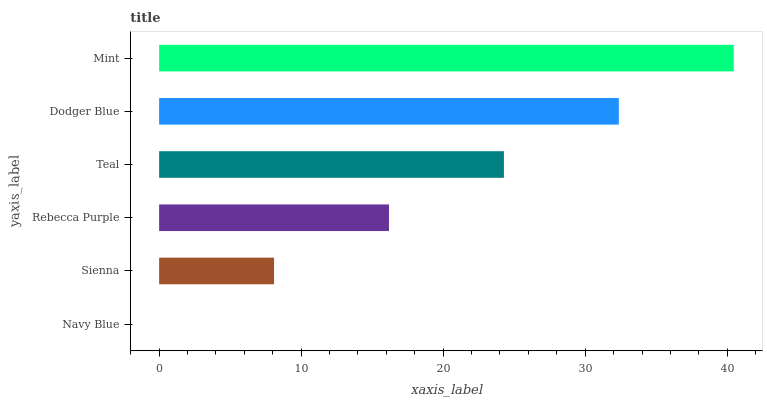Is Navy Blue the minimum?
Answer yes or no. Yes. Is Mint the maximum?
Answer yes or no. Yes. Is Sienna the minimum?
Answer yes or no. No. Is Sienna the maximum?
Answer yes or no. No. Is Sienna greater than Navy Blue?
Answer yes or no. Yes. Is Navy Blue less than Sienna?
Answer yes or no. Yes. Is Navy Blue greater than Sienna?
Answer yes or no. No. Is Sienna less than Navy Blue?
Answer yes or no. No. Is Teal the high median?
Answer yes or no. Yes. Is Rebecca Purple the low median?
Answer yes or no. Yes. Is Dodger Blue the high median?
Answer yes or no. No. Is Navy Blue the low median?
Answer yes or no. No. 